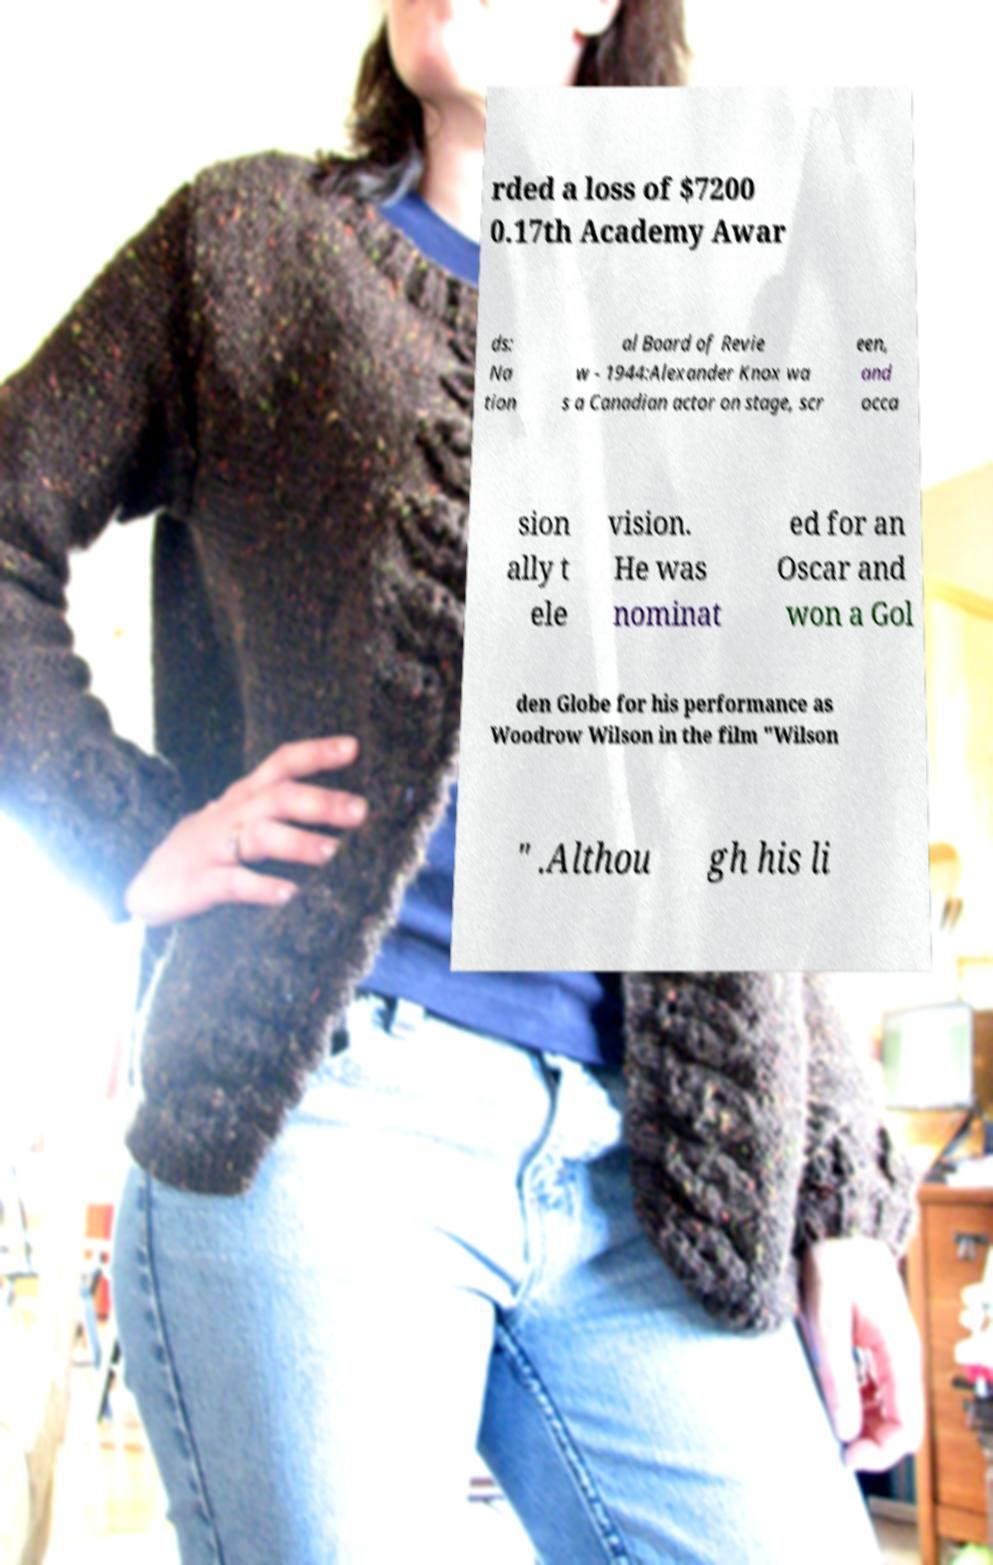For documentation purposes, I need the text within this image transcribed. Could you provide that? rded a loss of $7200 0.17th Academy Awar ds: Na tion al Board of Revie w - 1944:Alexander Knox wa s a Canadian actor on stage, scr een, and occa sion ally t ele vision. He was nominat ed for an Oscar and won a Gol den Globe for his performance as Woodrow Wilson in the film "Wilson " .Althou gh his li 